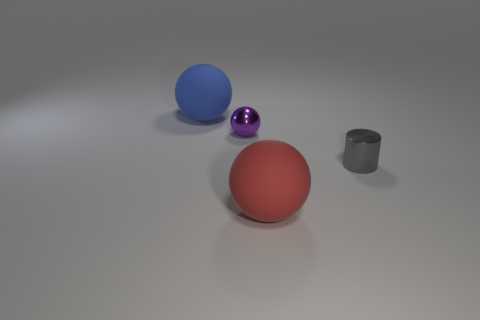There is a rubber ball that is in front of the purple sphere behind the tiny gray cylinder; what is its color?
Make the answer very short. Red. What number of other objects are the same color as the cylinder?
Offer a terse response. 0. What number of things are either blue rubber balls or things that are on the left side of the cylinder?
Provide a succinct answer. 3. There is a big thing behind the gray metal cylinder; what color is it?
Ensure brevity in your answer.  Blue. The big red object has what shape?
Provide a succinct answer. Sphere. What material is the tiny thing on the right side of the small shiny sphere behind the gray cylinder?
Your response must be concise. Metal. How many other things are made of the same material as the purple object?
Ensure brevity in your answer.  1. There is a red thing that is the same size as the blue ball; what is it made of?
Provide a short and direct response. Rubber. Are there more rubber things to the left of the purple metallic thing than blue objects right of the tiny cylinder?
Provide a short and direct response. Yes. Are there any blue matte things of the same shape as the small purple thing?
Keep it short and to the point. Yes. 